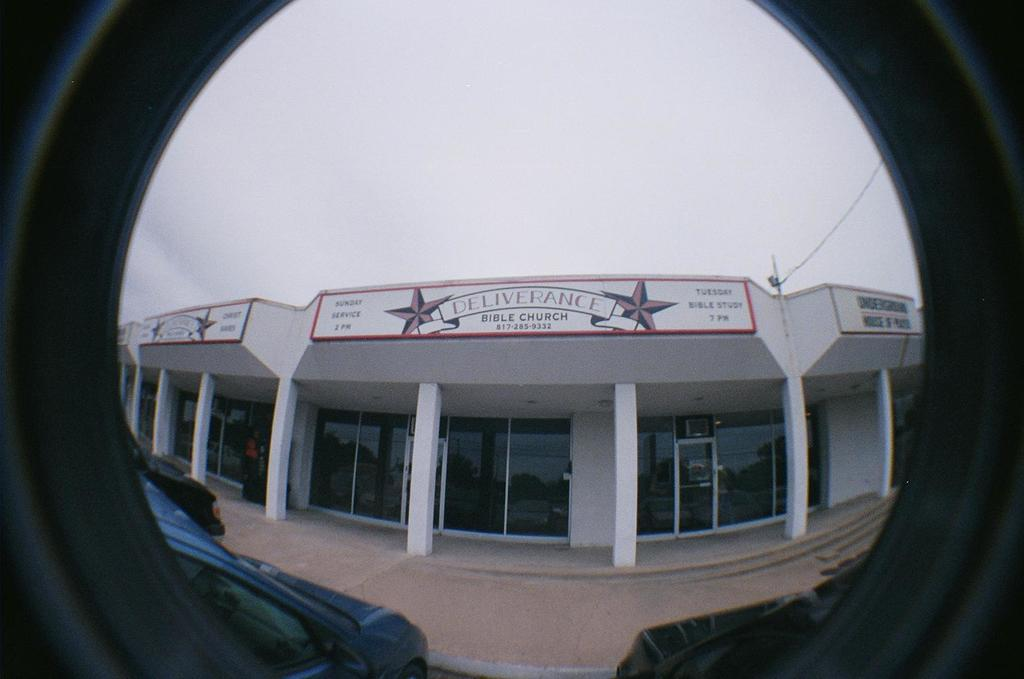What is the medium through which the image is viewed? The image is viewed through a glass. What type of structure is depicted in the image? There is a building with pillars in the image. Are there any words or symbols on the building? Yes, there is text on the building. What else can be seen in the image besides the building? There is a wire visible in the image. What is visible in the background of the image? The sky is visible in the image. How many geese are grazing in the field in the image? There is no field or geese present in the image; it features a building with pillars and text. What type of wind can be seen blowing through the image? There is no wind visible in the image, and the term "zephyr" refers to a gentle breeze, which cannot be seen. 